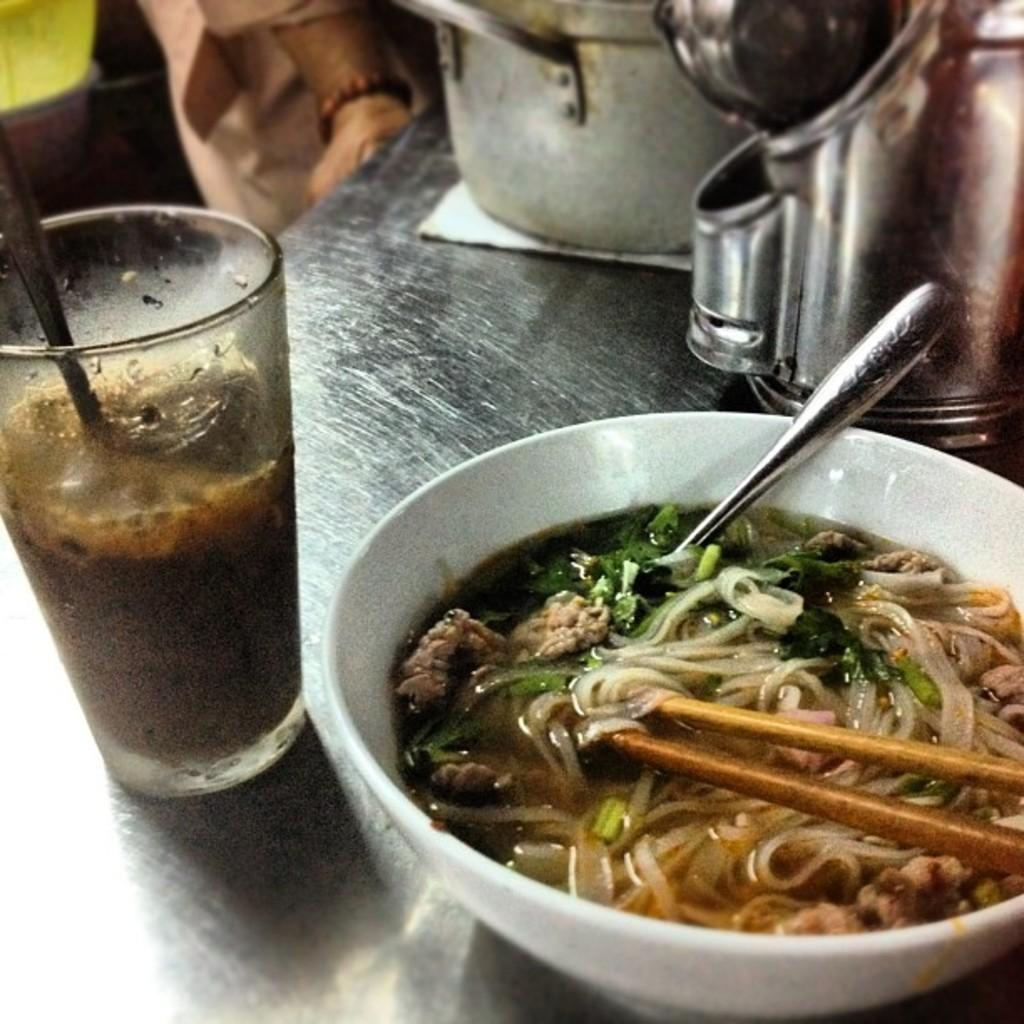What piece of furniture is present in the image? There is a table in the image. What is placed on the table? There are bowls and a glass on the table. What else can be seen on the table besides the bowls and glass? There are food items on the table. How many spiders are crawling on the table in the image? There are no spiders present in the image. Is there an oven visible on the table in the image? There is no oven present in the image. 